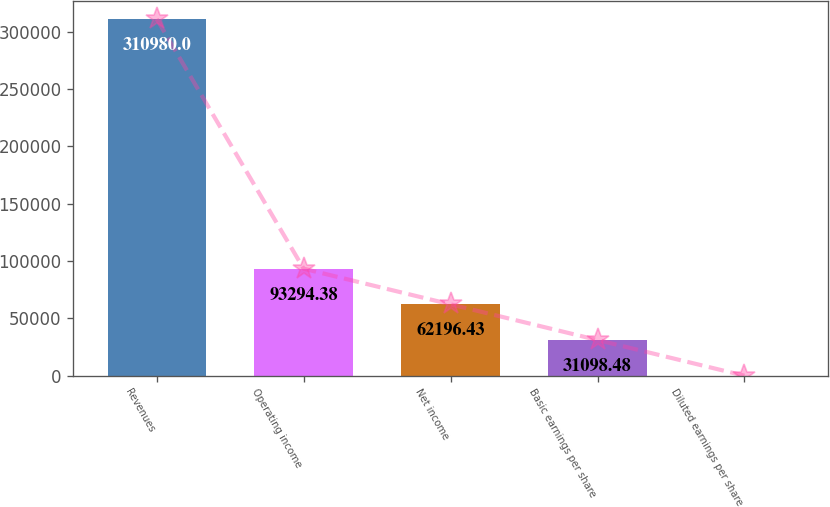Convert chart to OTSL. <chart><loc_0><loc_0><loc_500><loc_500><bar_chart><fcel>Revenues<fcel>Operating income<fcel>Net income<fcel>Basic earnings per share<fcel>Diluted earnings per share<nl><fcel>310980<fcel>93294.4<fcel>62196.4<fcel>31098.5<fcel>0.53<nl></chart> 